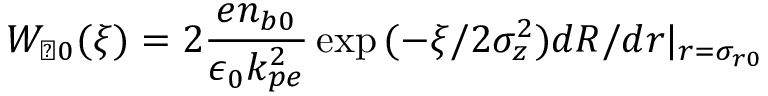Convert formula to latex. <formula><loc_0><loc_0><loc_500><loc_500>W _ { \perp 0 } ( \xi ) = 2 \frac { e n _ { b 0 } } { \epsilon _ { 0 } k _ { p e } ^ { 2 } } \exp { ( - \xi / 2 \sigma _ { z } ^ { 2 } ) } d R / d r | _ { r = \sigma _ { r 0 } }</formula> 